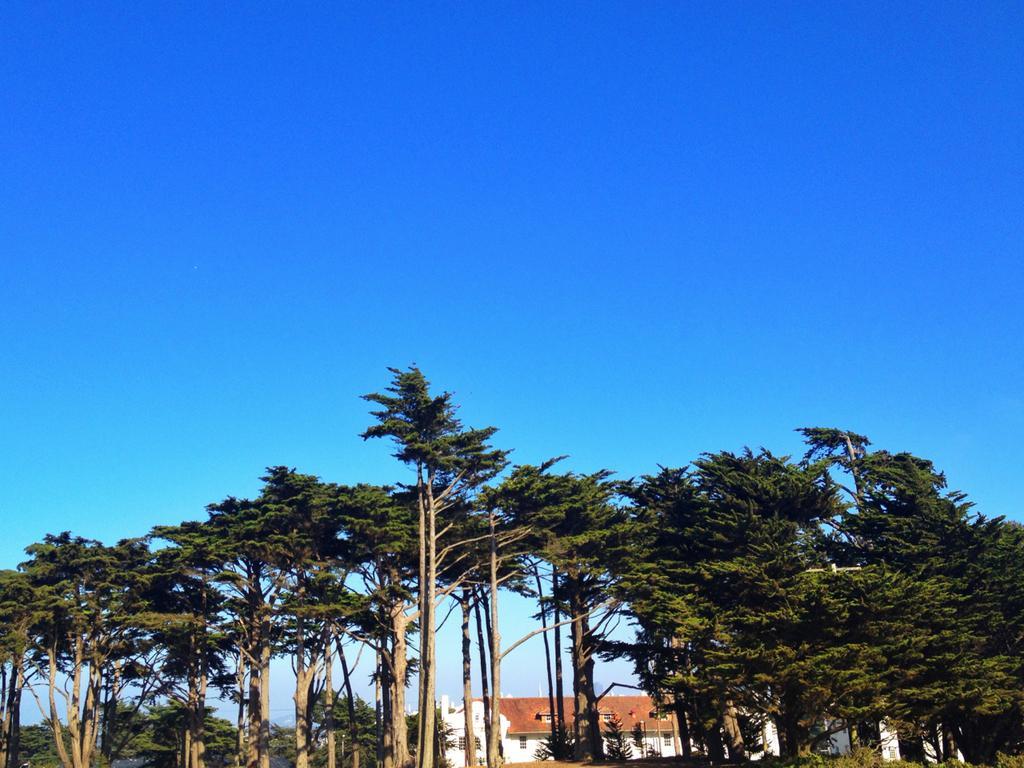Please provide a concise description of this image. There are plenty of tall trees and behind the trees there is a big house,in the background there is a sky. 